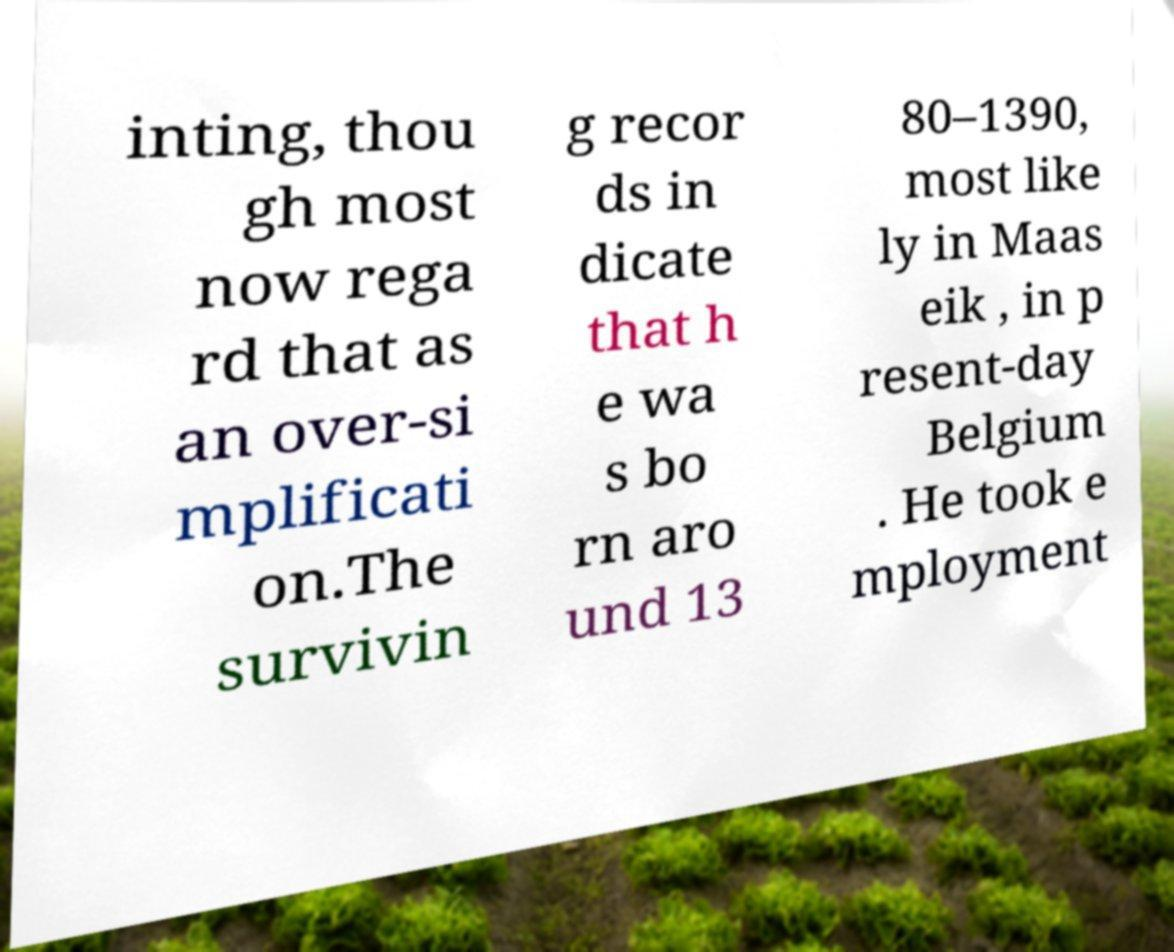For documentation purposes, I need the text within this image transcribed. Could you provide that? inting, thou gh most now rega rd that as an over-si mplificati on.The survivin g recor ds in dicate that h e wa s bo rn aro und 13 80–1390, most like ly in Maas eik , in p resent-day Belgium . He took e mployment 